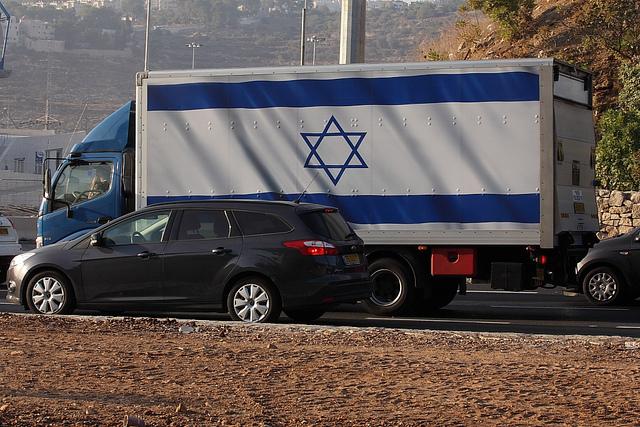What type of vehicle is this?
Answer briefly. Truck. Does the side of the truck look like a country's flag?
Concise answer only. Yes. Is the truck moving or parked?
Quick response, please. Moving. What religious symbol appears in this scene?
Quick response, please. Star of david. 